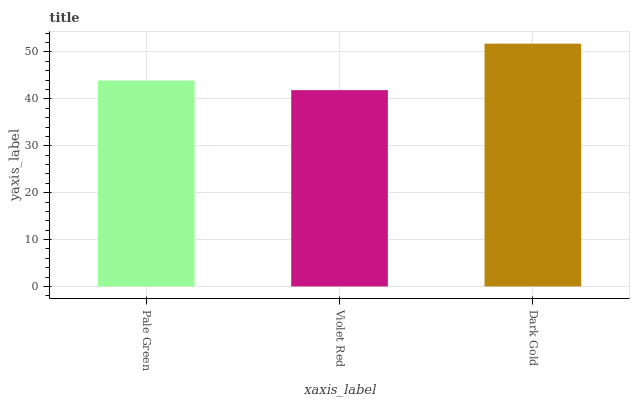Is Dark Gold the maximum?
Answer yes or no. Yes. Is Dark Gold the minimum?
Answer yes or no. No. Is Violet Red the maximum?
Answer yes or no. No. Is Dark Gold greater than Violet Red?
Answer yes or no. Yes. Is Violet Red less than Dark Gold?
Answer yes or no. Yes. Is Violet Red greater than Dark Gold?
Answer yes or no. No. Is Dark Gold less than Violet Red?
Answer yes or no. No. Is Pale Green the high median?
Answer yes or no. Yes. Is Pale Green the low median?
Answer yes or no. Yes. Is Dark Gold the high median?
Answer yes or no. No. Is Dark Gold the low median?
Answer yes or no. No. 